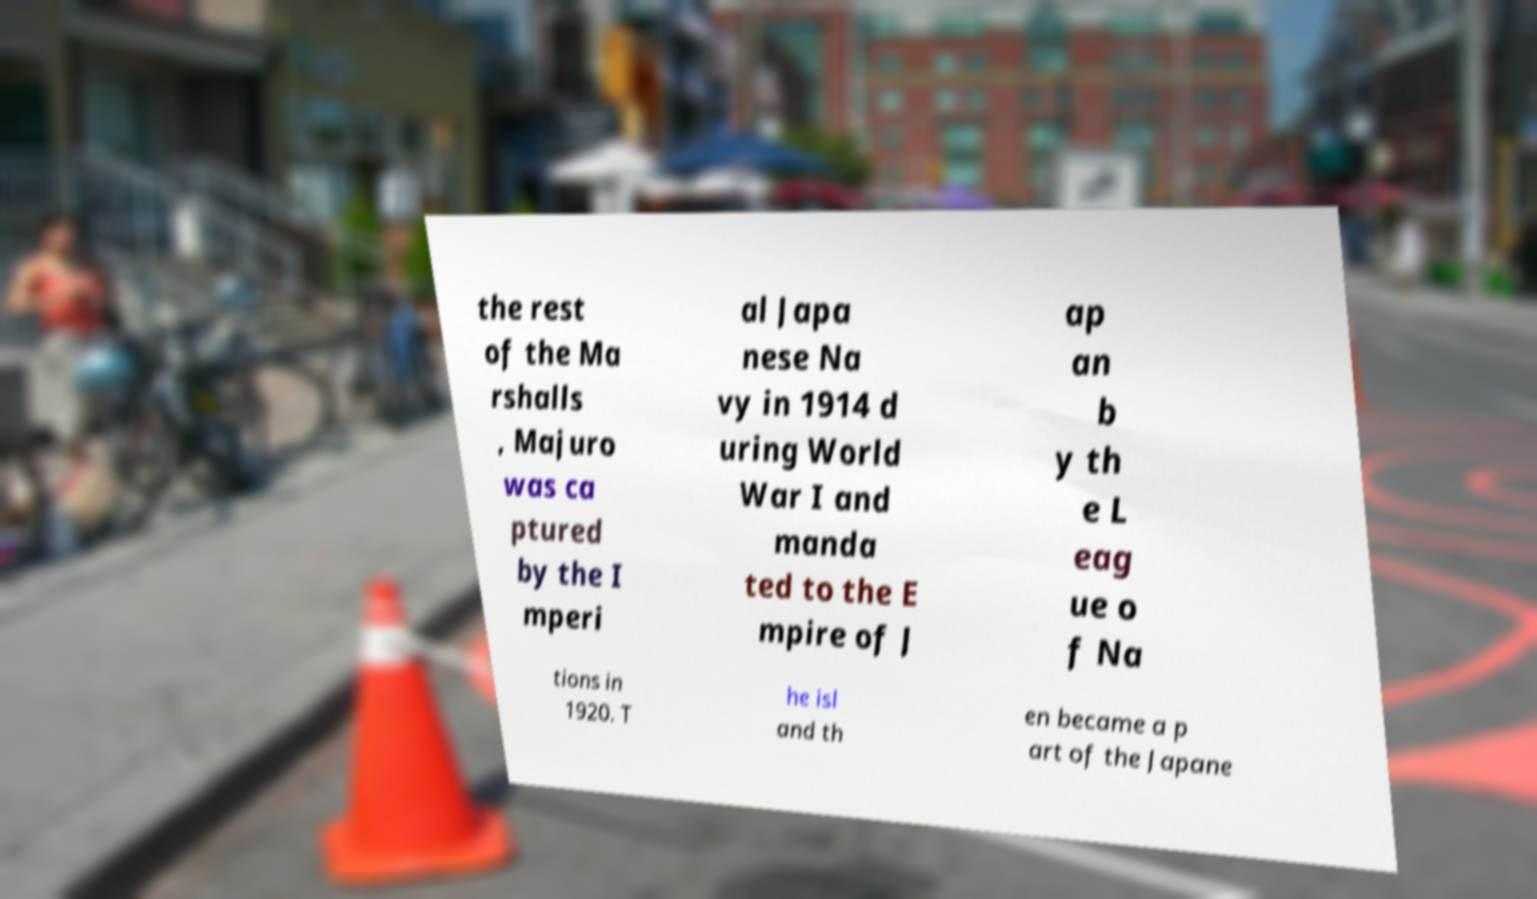Can you accurately transcribe the text from the provided image for me? the rest of the Ma rshalls , Majuro was ca ptured by the I mperi al Japa nese Na vy in 1914 d uring World War I and manda ted to the E mpire of J ap an b y th e L eag ue o f Na tions in 1920. T he isl and th en became a p art of the Japane 